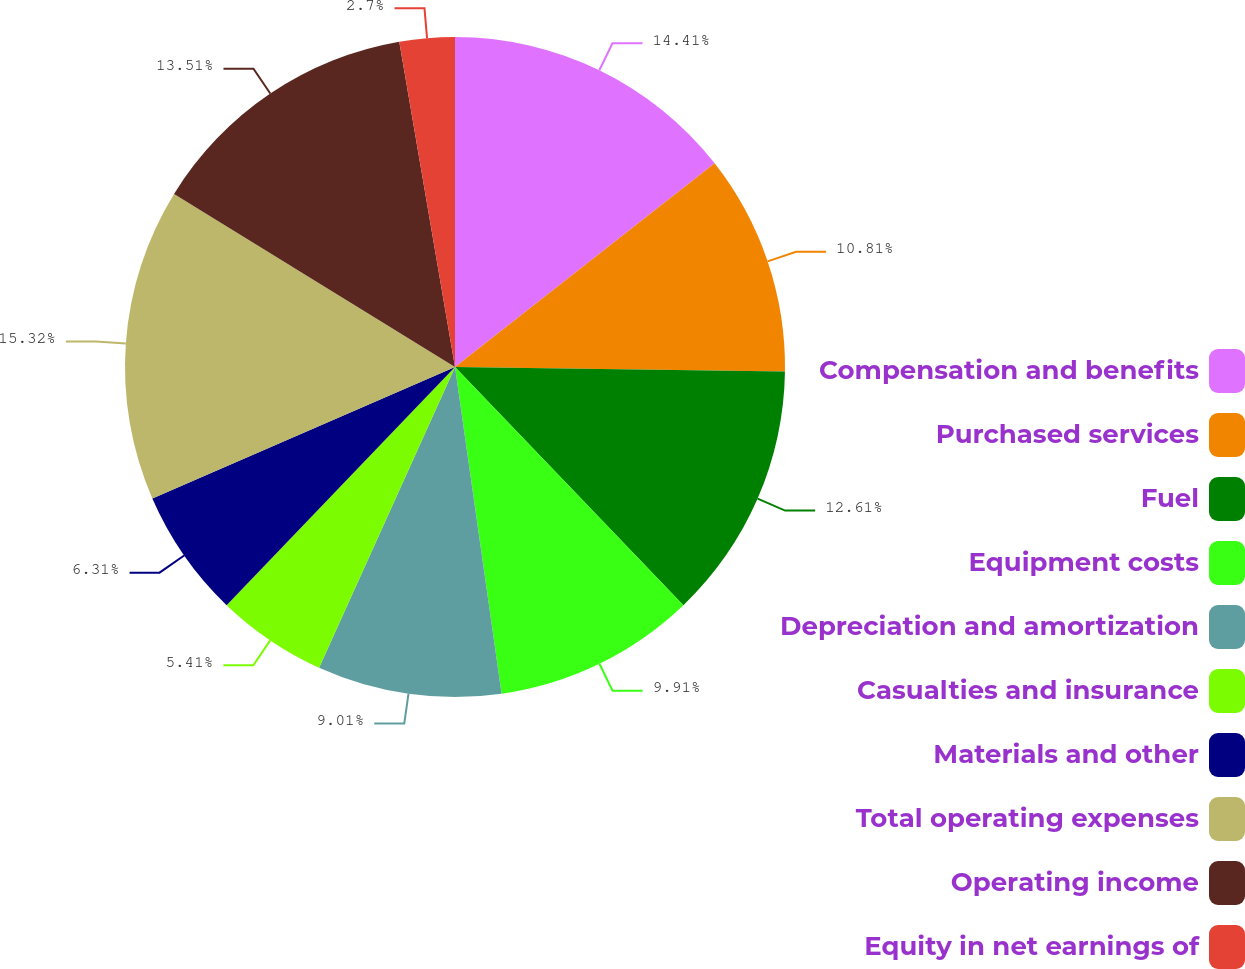Convert chart. <chart><loc_0><loc_0><loc_500><loc_500><pie_chart><fcel>Compensation and benefits<fcel>Purchased services<fcel>Fuel<fcel>Equipment costs<fcel>Depreciation and amortization<fcel>Casualties and insurance<fcel>Materials and other<fcel>Total operating expenses<fcel>Operating income<fcel>Equity in net earnings of<nl><fcel>14.41%<fcel>10.81%<fcel>12.61%<fcel>9.91%<fcel>9.01%<fcel>5.41%<fcel>6.31%<fcel>15.31%<fcel>13.51%<fcel>2.7%<nl></chart> 